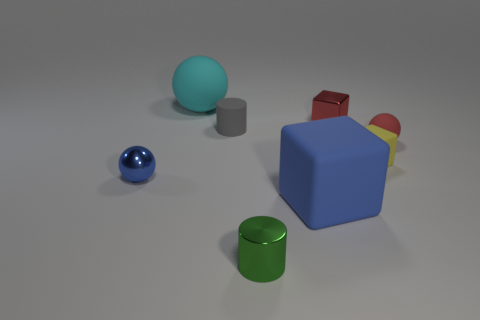Add 1 green cylinders. How many objects exist? 9 Subtract all cylinders. How many objects are left? 6 Add 5 cyan matte cylinders. How many cyan matte cylinders exist? 5 Subtract 1 yellow blocks. How many objects are left? 7 Subtract all gray cylinders. Subtract all gray things. How many objects are left? 6 Add 4 blocks. How many blocks are left? 7 